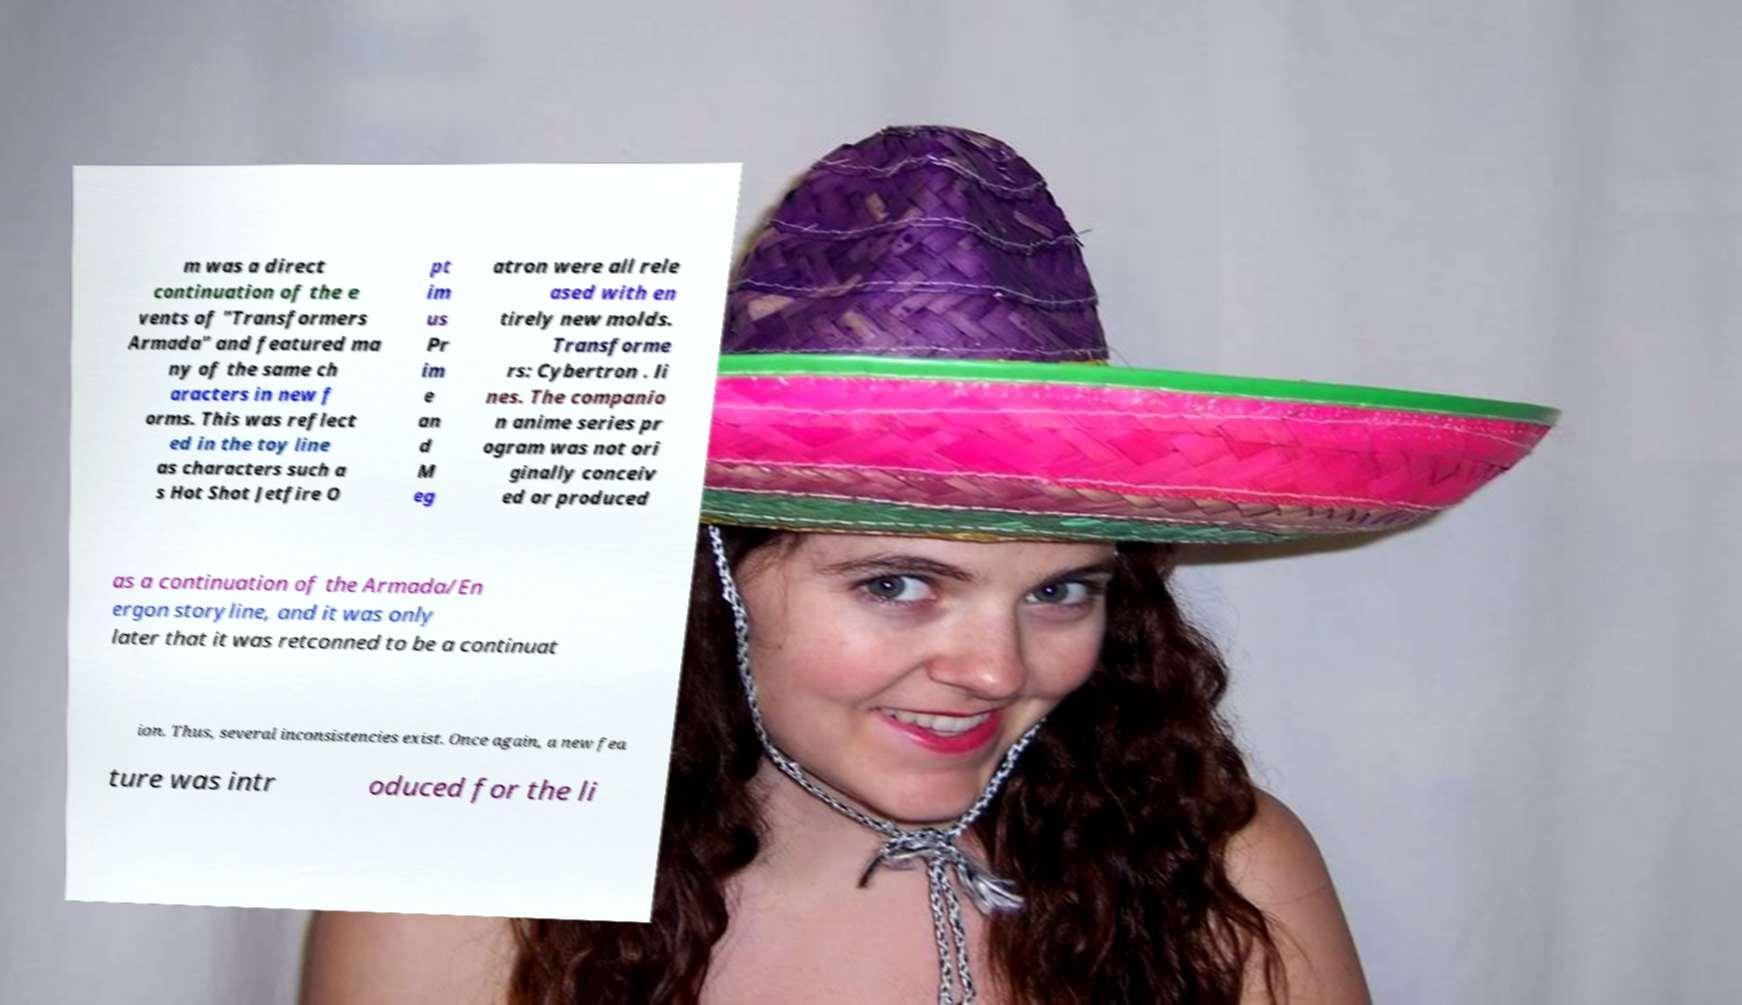Please read and relay the text visible in this image. What does it say? m was a direct continuation of the e vents of "Transformers Armada" and featured ma ny of the same ch aracters in new f orms. This was reflect ed in the toy line as characters such a s Hot Shot Jetfire O pt im us Pr im e an d M eg atron were all rele ased with en tirely new molds. Transforme rs: Cybertron . li nes. The companio n anime series pr ogram was not ori ginally conceiv ed or produced as a continuation of the Armada/En ergon storyline, and it was only later that it was retconned to be a continuat ion. Thus, several inconsistencies exist. Once again, a new fea ture was intr oduced for the li 